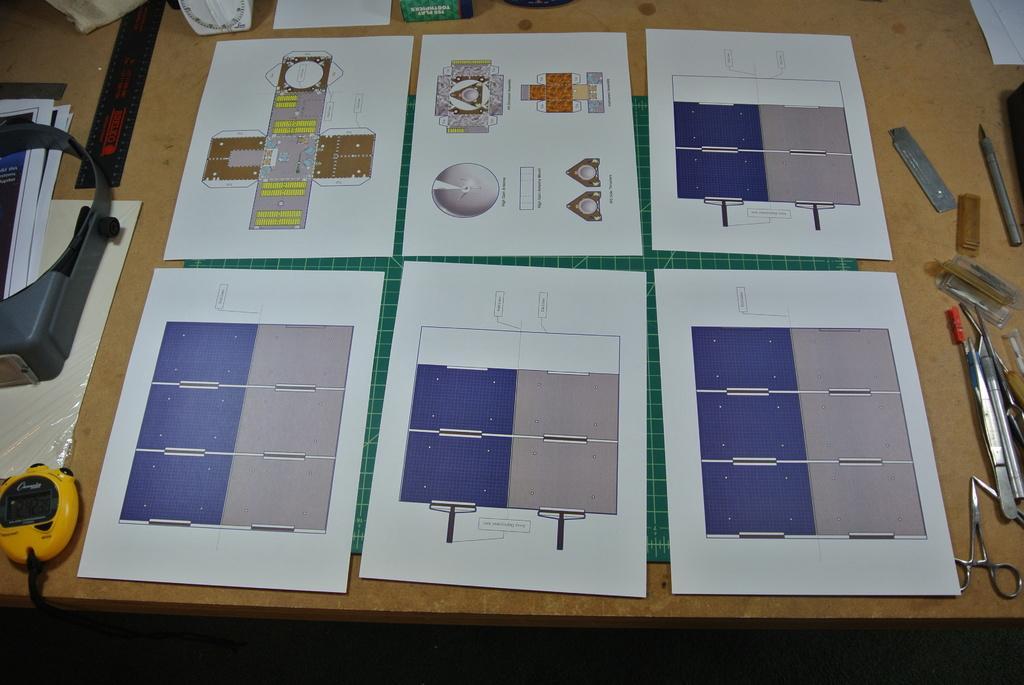Can you describe this image briefly? In this picture I can see papers, scissors, cutting mat and some other objects on the table. 